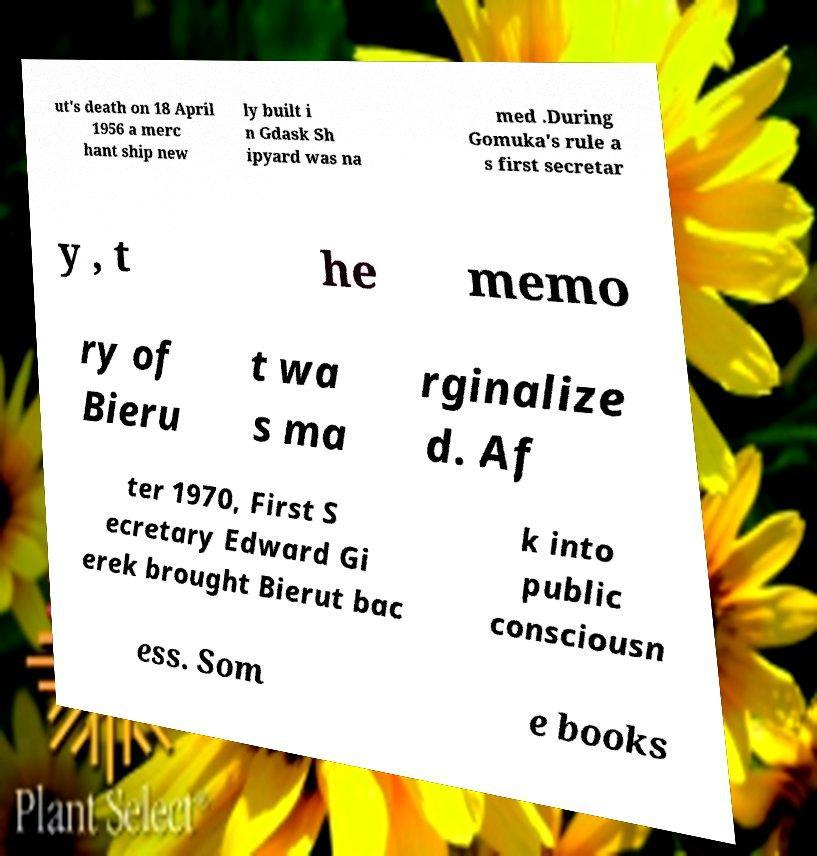Can you read and provide the text displayed in the image?This photo seems to have some interesting text. Can you extract and type it out for me? ut's death on 18 April 1956 a merc hant ship new ly built i n Gdask Sh ipyard was na med .During Gomuka's rule a s first secretar y , t he memo ry of Bieru t wa s ma rginalize d. Af ter 1970, First S ecretary Edward Gi erek brought Bierut bac k into public consciousn ess. Som e books 